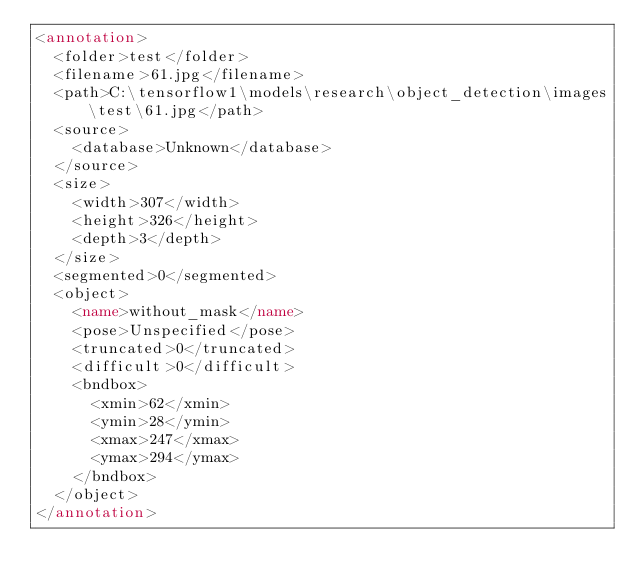Convert code to text. <code><loc_0><loc_0><loc_500><loc_500><_XML_><annotation>
	<folder>test</folder>
	<filename>61.jpg</filename>
	<path>C:\tensorflow1\models\research\object_detection\images\test\61.jpg</path>
	<source>
		<database>Unknown</database>
	</source>
	<size>
		<width>307</width>
		<height>326</height>
		<depth>3</depth>
	</size>
	<segmented>0</segmented>
	<object>
		<name>without_mask</name>
		<pose>Unspecified</pose>
		<truncated>0</truncated>
		<difficult>0</difficult>
		<bndbox>
			<xmin>62</xmin>
			<ymin>28</ymin>
			<xmax>247</xmax>
			<ymax>294</ymax>
		</bndbox>
	</object>
</annotation>
</code> 